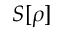Convert formula to latex. <formula><loc_0><loc_0><loc_500><loc_500>S [ \rho ]</formula> 